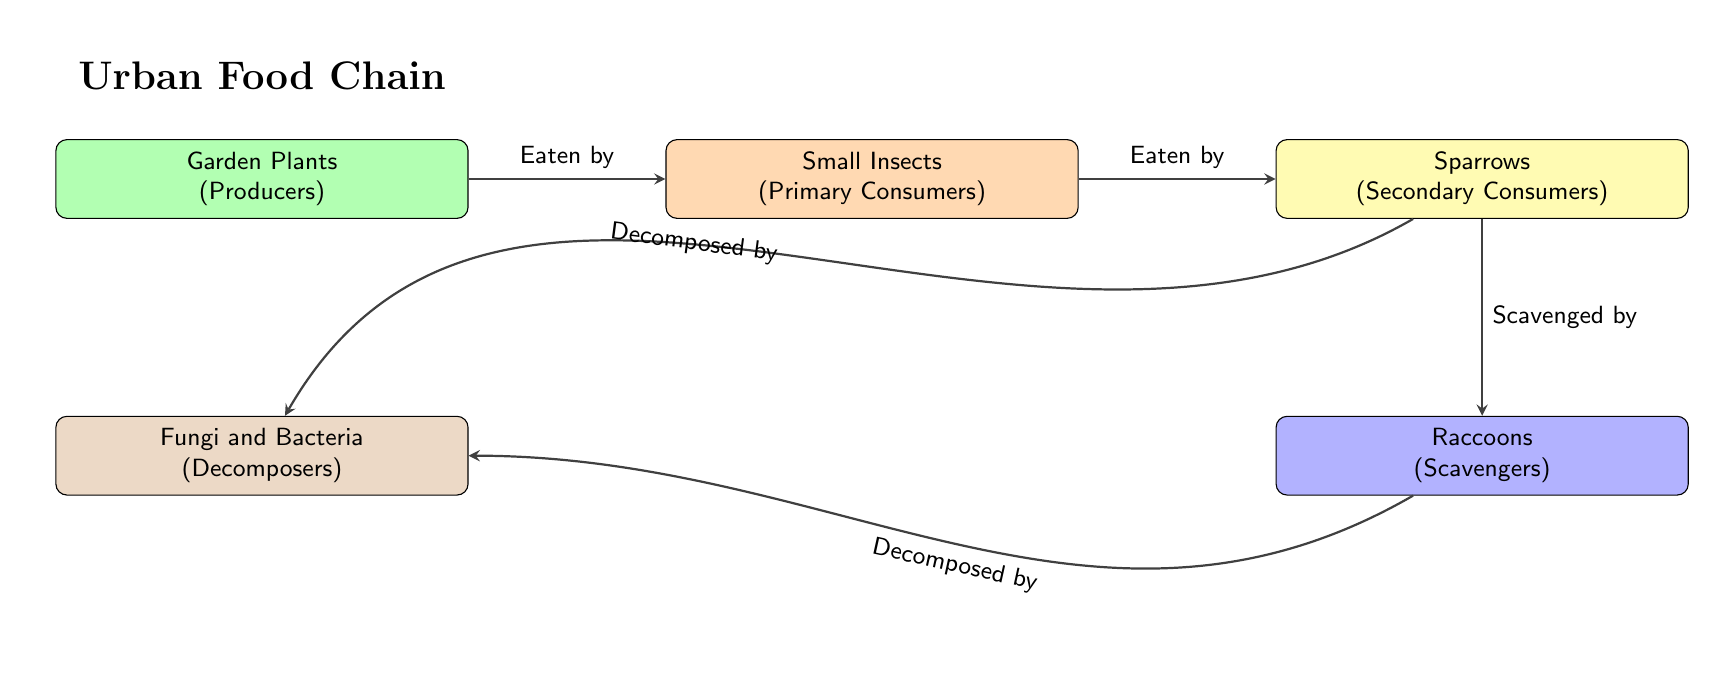What is the first component in the urban food chain? The first component is the "Garden Plants," which is labeled as producers. In the diagram, the "Garden Plants" node is positioned at the top, indicating that it is the starting point of the food chain.
Answer: Garden Plants How many total components are in the urban food chain? By counting the components displayed in the diagram, there are five nodes: Garden Plants, Small Insects, Sparrows, Raccoons, and Fungi and Bacteria. Thus, the total number is five.
Answer: 5 What do small insects eat in this food chain? According to the diagram, small insects eat the "Garden Plants," which is indicated by the arrow flowing from the "Garden Plants" to the "Small Insects," labeled as "Eaten by."
Answer: Garden Plants Which component is classified as a secondary consumer? The "Sparrows" are classified as secondary consumers. This is evident from the diagram where "Sparrows" is positioned to the right of "Small Insects," and they consume them.
Answer: Sparrows How do raccoons relate to the decomposers in this diagram? Raccoons, which are scavengers, are connected to decomposers through an arrow indicating "Decomposed by." This shows that after raccoons scavenge, the remains are decomposed by fungi and bacteria, completing the cycle of matter in this food chain.
Answer: Decomposed by How many different types of consumers are present in the urban food chain? There are two distinct types of consumers in the food chain: primary consumers (small insects) and secondary consumers (sparrows). Each type represents a different level in the chain of energy transfer.
Answer: 2 What is the role of decomposers in this urban food chain? The role of decomposers (fungi and bacteria) is to break down dead organisms, including remains of both raccoons and sparrows, indicating their importance in recycling nutrients back into the soil. In this diagram, they are positioned below the producers and consumers, demonstrating their foundational role in the ecosystem.
Answer: Recycling nutrients Which component is located directly above the raccoons? The "Sparrows" component is directly above the raccoons in the diagram, which can be confirmed by looking at the positioning of the entities in the representation.
Answer: Sparrows Who is a primary consumer in the food chain? The "Small Insects" are categorized as primary consumers. They feed on the producers, which are the garden plants, as shown in the diagram's flow.
Answer: Small Insects 